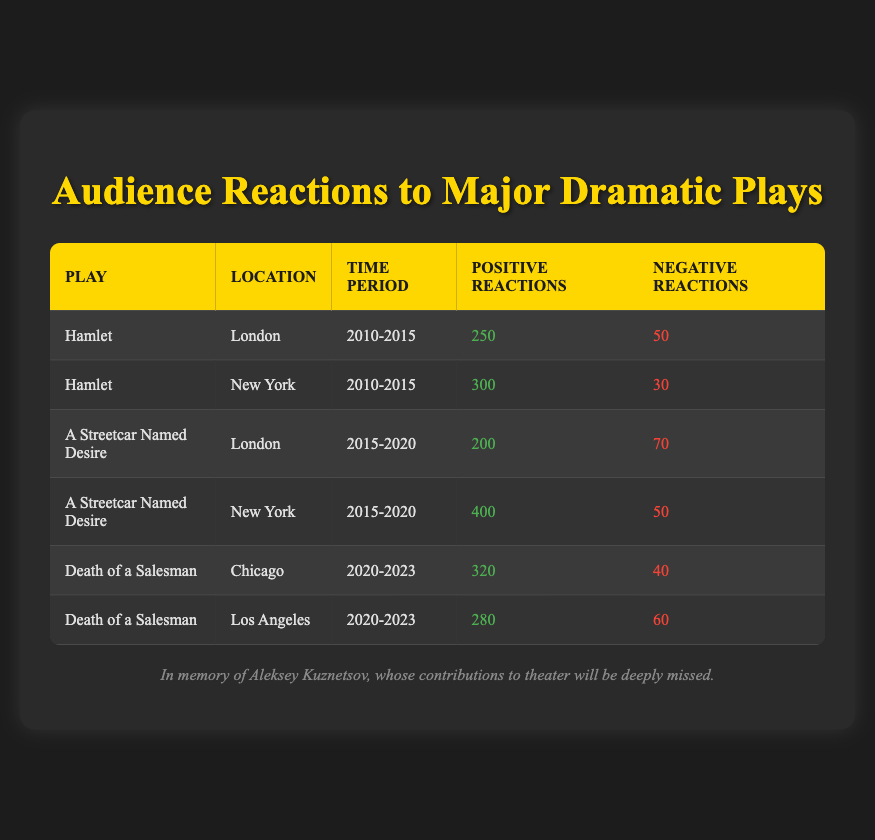What were the positive reactions to "A Streetcar Named Desire" in New York during 2015-2020? The table shows that in New York, "A Streetcar Named Desire" had positive reactions counted at 400 during the time period of 2015-2020.
Answer: 400 What is the total number of negative reactions for "Hamlet" during the period 2010-2015 in both London and New York? For London, there are 50 negative reactions for "Hamlet" and for New York, there are 30 negative reactions. Summing these gives 50 + 30 = 80 negative reactions total.
Answer: 80 Was the audience reaction to "Death of a Salesman" more positive in Chicago than in Los Angeles between 2020-2023? In Chicago, the positive reactions were 320, while in Los Angeles they were 280. Since 320 is greater than 280, the audience reaction was indeed more positive in Chicago.
Answer: Yes How many more positive reactions did "Hamlet" receive in New York compared to London from 2010-2015? "Hamlet" had 300 positive reactions in New York and 250 in London. Thus, 300 - 250 = 50 more positive reactions in New York.
Answer: 50 What percentage of reactions were negative for "A Streetcar Named Desire" in London during 2015-2020? There were 200 positive and 70 negative reactions in London for "A Streetcar Named Desire". To find the total reactions, sum them: 200 + 70 = 270. The percentage of negative reactions is (70 / 270) * 100 ≈ 25.93%.
Answer: Approximately 25.93% Which location had the highest total negative reactions across all plays and time periods? First, calculate the total negative reactions per location: London has 50 (Hamlet) + 70 (A Streetcar Named Desire) = 120, New York has 30 (Hamlet) + 50 (A Streetcar Named Desire) = 80, Chicago has 40 (Death of a Salesman) = 40, and Los Angeles has 60 (Death of a Salesman) = 60. The highest total is from London with 120 negative reactions.
Answer: London In which city did "Death of a Salesman" receive its highest number of reactions, combining both positive and negative? In Chicago, there were 320 positive and 40 negative reactions totaling 360. In Los Angeles, there were 280 positive and 60 negative, totaling 340. Therefore, Chicago had the highest combined reactions with 360.
Answer: Chicago Was there a greater number of total positive reactions for "A Streetcar Named Desire" compared to "Hamlet" during their respective time periods in New York? For "A Streetcar Named Desire" in New York, there were 400 positive reactions. For "Hamlet," there were 300. Since 400 is greater than 300, "A Streetcar Named Desire" had greater positive reactions in New York.
Answer: Yes 